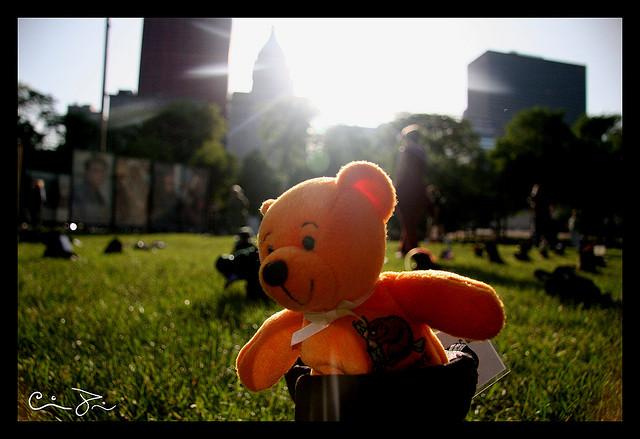Is this a child's toy?
Concise answer only. Yes. Why is the teddy bear's ear glowing?
Quick response, please. Sunlight. Is this a happy teddy bear?
Be succinct. Yes. 